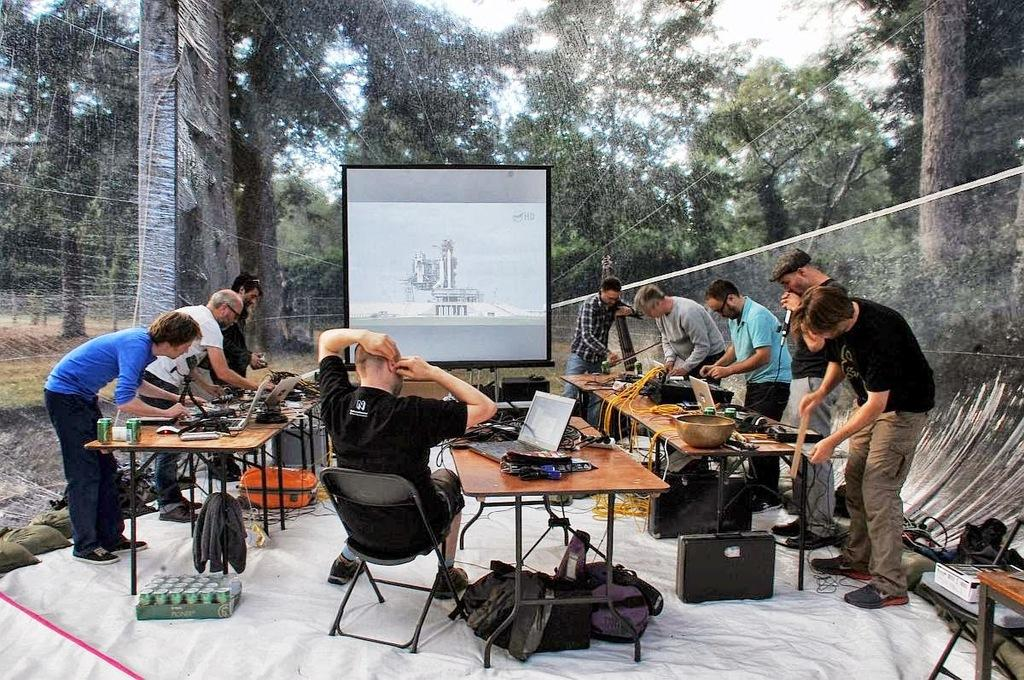How many people are present in the image? There are several people in the image. What are the people doing in the image? The people are working on a table. Can you describe the person located in the center of the image? The guy in the center of the image is looking at a screen. What type of liquid is being used on the canvas in the image? There is no canvas or liquid present in the image. What kind of rock is visible in the image? There is no rock visible in the image. 